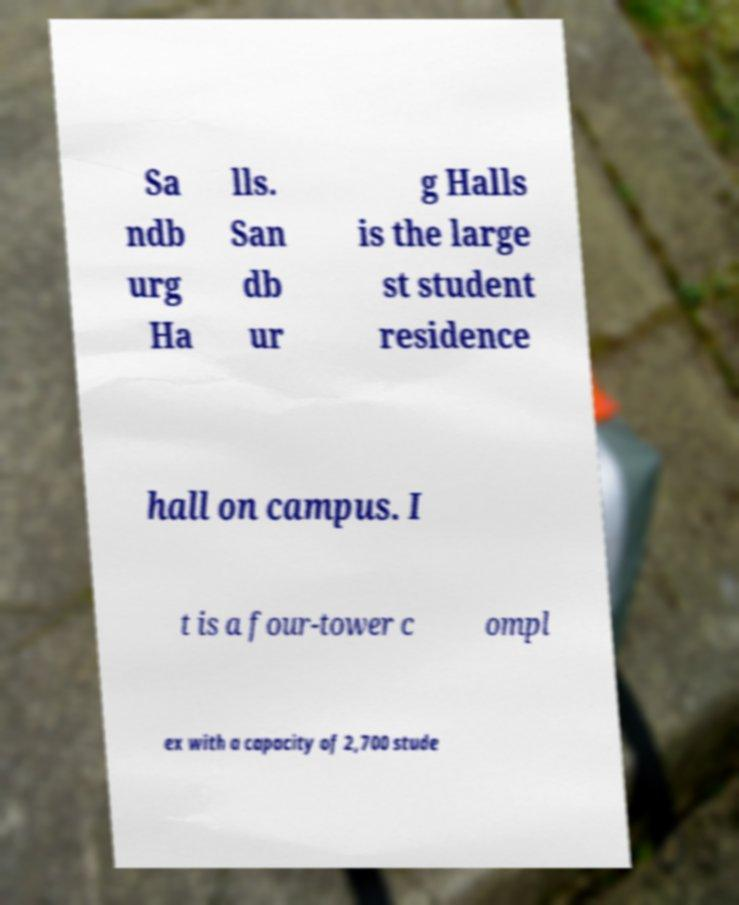I need the written content from this picture converted into text. Can you do that? Sa ndb urg Ha lls. San db ur g Halls is the large st student residence hall on campus. I t is a four-tower c ompl ex with a capacity of 2,700 stude 